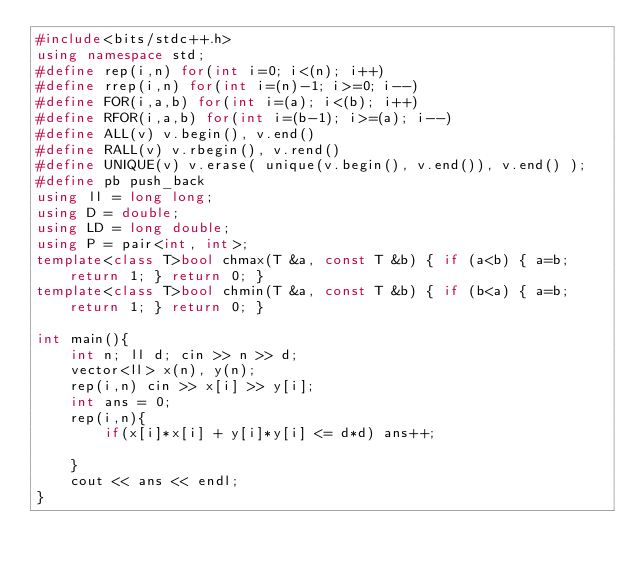Convert code to text. <code><loc_0><loc_0><loc_500><loc_500><_C++_>#include<bits/stdc++.h>
using namespace std;
#define rep(i,n) for(int i=0; i<(n); i++)
#define rrep(i,n) for(int i=(n)-1; i>=0; i--)
#define FOR(i,a,b) for(int i=(a); i<(b); i++)
#define RFOR(i,a,b) for(int i=(b-1); i>=(a); i--)
#define ALL(v) v.begin(), v.end()
#define RALL(v) v.rbegin(), v.rend()
#define UNIQUE(v) v.erase( unique(v.begin(), v.end()), v.end() );
#define pb push_back
using ll = long long;
using D = double;
using LD = long double;
using P = pair<int, int>;
template<class T>bool chmax(T &a, const T &b) { if (a<b) { a=b; return 1; } return 0; }
template<class T>bool chmin(T &a, const T &b) { if (b<a) { a=b; return 1; } return 0; }

int main(){
    int n; ll d; cin >> n >> d;
    vector<ll> x(n), y(n);
    rep(i,n) cin >> x[i] >> y[i];
    int ans = 0;
    rep(i,n){
        if(x[i]*x[i] + y[i]*y[i] <= d*d) ans++;

    }
    cout << ans << endl;
}
</code> 